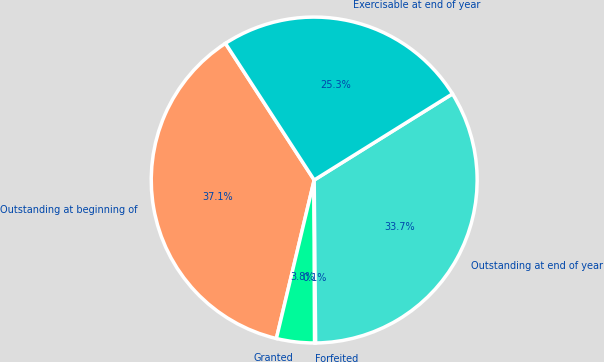Convert chart to OTSL. <chart><loc_0><loc_0><loc_500><loc_500><pie_chart><fcel>Outstanding at beginning of<fcel>Granted<fcel>Forfeited<fcel>Outstanding at end of year<fcel>Exercisable at end of year<nl><fcel>37.11%<fcel>3.77%<fcel>0.1%<fcel>33.73%<fcel>25.3%<nl></chart> 